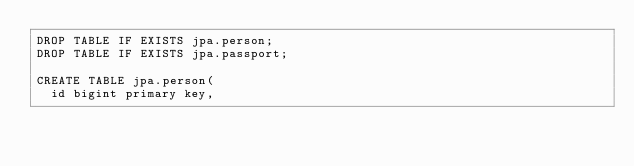Convert code to text. <code><loc_0><loc_0><loc_500><loc_500><_SQL_>DROP TABLE IF EXISTS jpa.person;
DROP TABLE IF EXISTS jpa.passport;

CREATE TABLE jpa.person(
	id bigint primary key,</code> 